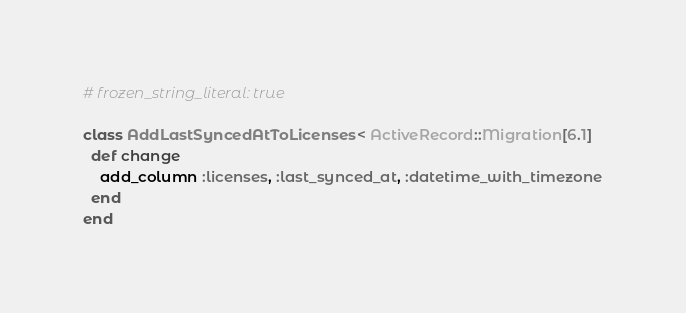Convert code to text. <code><loc_0><loc_0><loc_500><loc_500><_Ruby_># frozen_string_literal: true

class AddLastSyncedAtToLicenses < ActiveRecord::Migration[6.1]
  def change
    add_column :licenses, :last_synced_at, :datetime_with_timezone
  end
end
</code> 